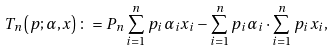Convert formula to latex. <formula><loc_0><loc_0><loc_500><loc_500>T _ { n } \left ( p ; \alpha , x \right ) \colon = P _ { n } \sum _ { i = 1 } ^ { n } p _ { i } \alpha _ { i } x _ { i } - \sum _ { i = 1 } ^ { n } p _ { i } \alpha _ { i } \cdot \sum _ { i = 1 } ^ { n } p _ { i } x _ { i } ,</formula> 